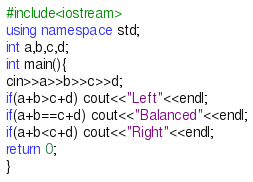<code> <loc_0><loc_0><loc_500><loc_500><_C++_>#include<iostream>
using namespace std;
int a,b,c,d;
int main(){
cin>>a>>b>>c>>d;
if(a+b>c+d) cout<<"Left"<<endl;
if(a+b==c+d) cout<<"Balanced"<<endl;
if(a+b<c+d) cout<<"Right"<<endl;
return 0;
}</code> 